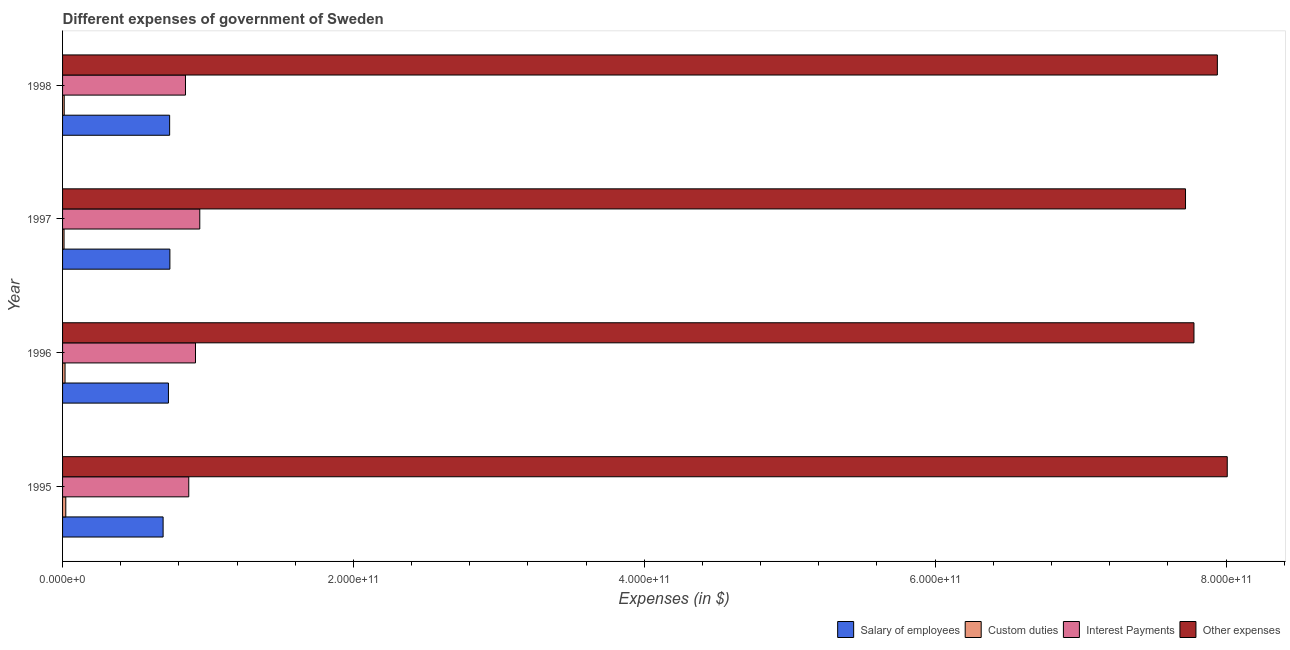How many different coloured bars are there?
Your answer should be compact. 4. Are the number of bars on each tick of the Y-axis equal?
Keep it short and to the point. Yes. How many bars are there on the 3rd tick from the bottom?
Provide a short and direct response. 4. What is the label of the 2nd group of bars from the top?
Offer a very short reply. 1997. What is the amount spent on salary of employees in 1996?
Provide a succinct answer. 7.28e+1. Across all years, what is the maximum amount spent on salary of employees?
Offer a terse response. 7.38e+1. Across all years, what is the minimum amount spent on custom duties?
Provide a succinct answer. 1.02e+09. In which year was the amount spent on salary of employees maximum?
Give a very brief answer. 1997. In which year was the amount spent on interest payments minimum?
Keep it short and to the point. 1998. What is the total amount spent on other expenses in the graph?
Provide a succinct answer. 3.15e+12. What is the difference between the amount spent on interest payments in 1997 and that in 1998?
Offer a very short reply. 9.84e+09. What is the difference between the amount spent on salary of employees in 1996 and the amount spent on interest payments in 1998?
Ensure brevity in your answer.  -1.17e+1. What is the average amount spent on other expenses per year?
Give a very brief answer. 7.86e+11. In the year 1998, what is the difference between the amount spent on other expenses and amount spent on interest payments?
Your response must be concise. 7.10e+11. In how many years, is the amount spent on other expenses greater than 400000000000 $?
Provide a short and direct response. 4. Is the difference between the amount spent on interest payments in 1995 and 1997 greater than the difference between the amount spent on other expenses in 1995 and 1997?
Offer a terse response. No. What is the difference between the highest and the second highest amount spent on interest payments?
Your answer should be compact. 2.94e+09. What is the difference between the highest and the lowest amount spent on other expenses?
Provide a succinct answer. 2.87e+1. In how many years, is the amount spent on interest payments greater than the average amount spent on interest payments taken over all years?
Your response must be concise. 2. Is it the case that in every year, the sum of the amount spent on custom duties and amount spent on other expenses is greater than the sum of amount spent on salary of employees and amount spent on interest payments?
Ensure brevity in your answer.  No. What does the 4th bar from the top in 1997 represents?
Your answer should be compact. Salary of employees. What does the 3rd bar from the bottom in 1998 represents?
Your answer should be very brief. Interest Payments. Are all the bars in the graph horizontal?
Keep it short and to the point. Yes. How many years are there in the graph?
Your response must be concise. 4. What is the difference between two consecutive major ticks on the X-axis?
Offer a very short reply. 2.00e+11. Are the values on the major ticks of X-axis written in scientific E-notation?
Offer a very short reply. Yes. Does the graph contain any zero values?
Provide a short and direct response. No. What is the title of the graph?
Offer a terse response. Different expenses of government of Sweden. Does "Industry" appear as one of the legend labels in the graph?
Provide a short and direct response. No. What is the label or title of the X-axis?
Make the answer very short. Expenses (in $). What is the label or title of the Y-axis?
Give a very brief answer. Year. What is the Expenses (in $) in Salary of employees in 1995?
Give a very brief answer. 6.91e+1. What is the Expenses (in $) in Custom duties in 1995?
Your answer should be compact. 2.22e+09. What is the Expenses (in $) of Interest Payments in 1995?
Make the answer very short. 8.68e+1. What is the Expenses (in $) of Other expenses in 1995?
Provide a short and direct response. 8.01e+11. What is the Expenses (in $) of Salary of employees in 1996?
Your response must be concise. 7.28e+1. What is the Expenses (in $) in Custom duties in 1996?
Give a very brief answer. 1.70e+09. What is the Expenses (in $) in Interest Payments in 1996?
Offer a terse response. 9.14e+1. What is the Expenses (in $) of Other expenses in 1996?
Provide a short and direct response. 7.78e+11. What is the Expenses (in $) of Salary of employees in 1997?
Your answer should be very brief. 7.38e+1. What is the Expenses (in $) of Custom duties in 1997?
Provide a succinct answer. 1.02e+09. What is the Expenses (in $) of Interest Payments in 1997?
Ensure brevity in your answer.  9.44e+1. What is the Expenses (in $) of Other expenses in 1997?
Provide a short and direct response. 7.72e+11. What is the Expenses (in $) of Salary of employees in 1998?
Your answer should be very brief. 7.36e+1. What is the Expenses (in $) of Custom duties in 1998?
Keep it short and to the point. 1.14e+09. What is the Expenses (in $) of Interest Payments in 1998?
Give a very brief answer. 8.45e+1. What is the Expenses (in $) of Other expenses in 1998?
Offer a very short reply. 7.94e+11. Across all years, what is the maximum Expenses (in $) in Salary of employees?
Your answer should be very brief. 7.38e+1. Across all years, what is the maximum Expenses (in $) in Custom duties?
Keep it short and to the point. 2.22e+09. Across all years, what is the maximum Expenses (in $) in Interest Payments?
Offer a very short reply. 9.44e+1. Across all years, what is the maximum Expenses (in $) of Other expenses?
Provide a succinct answer. 8.01e+11. Across all years, what is the minimum Expenses (in $) of Salary of employees?
Provide a short and direct response. 6.91e+1. Across all years, what is the minimum Expenses (in $) in Custom duties?
Provide a succinct answer. 1.02e+09. Across all years, what is the minimum Expenses (in $) in Interest Payments?
Give a very brief answer. 8.45e+1. Across all years, what is the minimum Expenses (in $) of Other expenses?
Ensure brevity in your answer.  7.72e+11. What is the total Expenses (in $) of Salary of employees in the graph?
Ensure brevity in your answer.  2.89e+11. What is the total Expenses (in $) in Custom duties in the graph?
Keep it short and to the point. 6.08e+09. What is the total Expenses (in $) in Interest Payments in the graph?
Give a very brief answer. 3.57e+11. What is the total Expenses (in $) of Other expenses in the graph?
Offer a terse response. 3.15e+12. What is the difference between the Expenses (in $) in Salary of employees in 1995 and that in 1996?
Make the answer very short. -3.67e+09. What is the difference between the Expenses (in $) of Custom duties in 1995 and that in 1996?
Provide a succinct answer. 5.17e+08. What is the difference between the Expenses (in $) in Interest Payments in 1995 and that in 1996?
Make the answer very short. -4.64e+09. What is the difference between the Expenses (in $) in Other expenses in 1995 and that in 1996?
Keep it short and to the point. 2.29e+1. What is the difference between the Expenses (in $) in Salary of employees in 1995 and that in 1997?
Make the answer very short. -4.67e+09. What is the difference between the Expenses (in $) in Custom duties in 1995 and that in 1997?
Offer a terse response. 1.20e+09. What is the difference between the Expenses (in $) of Interest Payments in 1995 and that in 1997?
Provide a short and direct response. -7.58e+09. What is the difference between the Expenses (in $) in Other expenses in 1995 and that in 1997?
Ensure brevity in your answer.  2.87e+1. What is the difference between the Expenses (in $) of Salary of employees in 1995 and that in 1998?
Offer a very short reply. -4.49e+09. What is the difference between the Expenses (in $) of Custom duties in 1995 and that in 1998?
Your answer should be very brief. 1.08e+09. What is the difference between the Expenses (in $) in Interest Payments in 1995 and that in 1998?
Make the answer very short. 2.26e+09. What is the difference between the Expenses (in $) of Other expenses in 1995 and that in 1998?
Your answer should be very brief. 6.80e+09. What is the difference between the Expenses (in $) in Salary of employees in 1996 and that in 1997?
Ensure brevity in your answer.  -1.00e+09. What is the difference between the Expenses (in $) of Custom duties in 1996 and that in 1997?
Make the answer very short. 6.84e+08. What is the difference between the Expenses (in $) in Interest Payments in 1996 and that in 1997?
Your response must be concise. -2.94e+09. What is the difference between the Expenses (in $) in Other expenses in 1996 and that in 1997?
Give a very brief answer. 5.81e+09. What is the difference between the Expenses (in $) of Salary of employees in 1996 and that in 1998?
Provide a succinct answer. -8.25e+08. What is the difference between the Expenses (in $) of Custom duties in 1996 and that in 1998?
Provide a short and direct response. 5.65e+08. What is the difference between the Expenses (in $) in Interest Payments in 1996 and that in 1998?
Your answer should be compact. 6.89e+09. What is the difference between the Expenses (in $) of Other expenses in 1996 and that in 1998?
Offer a very short reply. -1.61e+1. What is the difference between the Expenses (in $) in Salary of employees in 1997 and that in 1998?
Offer a terse response. 1.75e+08. What is the difference between the Expenses (in $) of Custom duties in 1997 and that in 1998?
Your answer should be compact. -1.19e+08. What is the difference between the Expenses (in $) in Interest Payments in 1997 and that in 1998?
Your answer should be compact. 9.84e+09. What is the difference between the Expenses (in $) of Other expenses in 1997 and that in 1998?
Make the answer very short. -2.19e+1. What is the difference between the Expenses (in $) in Salary of employees in 1995 and the Expenses (in $) in Custom duties in 1996?
Offer a very short reply. 6.74e+1. What is the difference between the Expenses (in $) of Salary of employees in 1995 and the Expenses (in $) of Interest Payments in 1996?
Give a very brief answer. -2.23e+1. What is the difference between the Expenses (in $) of Salary of employees in 1995 and the Expenses (in $) of Other expenses in 1996?
Provide a succinct answer. -7.09e+11. What is the difference between the Expenses (in $) of Custom duties in 1995 and the Expenses (in $) of Interest Payments in 1996?
Provide a short and direct response. -8.92e+1. What is the difference between the Expenses (in $) of Custom duties in 1995 and the Expenses (in $) of Other expenses in 1996?
Your answer should be compact. -7.76e+11. What is the difference between the Expenses (in $) in Interest Payments in 1995 and the Expenses (in $) in Other expenses in 1996?
Your answer should be compact. -6.91e+11. What is the difference between the Expenses (in $) of Salary of employees in 1995 and the Expenses (in $) of Custom duties in 1997?
Provide a succinct answer. 6.81e+1. What is the difference between the Expenses (in $) in Salary of employees in 1995 and the Expenses (in $) in Interest Payments in 1997?
Your answer should be compact. -2.52e+1. What is the difference between the Expenses (in $) of Salary of employees in 1995 and the Expenses (in $) of Other expenses in 1997?
Keep it short and to the point. -7.03e+11. What is the difference between the Expenses (in $) of Custom duties in 1995 and the Expenses (in $) of Interest Payments in 1997?
Your answer should be very brief. -9.21e+1. What is the difference between the Expenses (in $) in Custom duties in 1995 and the Expenses (in $) in Other expenses in 1997?
Provide a short and direct response. -7.70e+11. What is the difference between the Expenses (in $) of Interest Payments in 1995 and the Expenses (in $) of Other expenses in 1997?
Keep it short and to the point. -6.85e+11. What is the difference between the Expenses (in $) in Salary of employees in 1995 and the Expenses (in $) in Custom duties in 1998?
Your answer should be compact. 6.80e+1. What is the difference between the Expenses (in $) of Salary of employees in 1995 and the Expenses (in $) of Interest Payments in 1998?
Provide a short and direct response. -1.54e+1. What is the difference between the Expenses (in $) in Salary of employees in 1995 and the Expenses (in $) in Other expenses in 1998?
Offer a very short reply. -7.25e+11. What is the difference between the Expenses (in $) in Custom duties in 1995 and the Expenses (in $) in Interest Payments in 1998?
Give a very brief answer. -8.23e+1. What is the difference between the Expenses (in $) in Custom duties in 1995 and the Expenses (in $) in Other expenses in 1998?
Your answer should be compact. -7.92e+11. What is the difference between the Expenses (in $) in Interest Payments in 1995 and the Expenses (in $) in Other expenses in 1998?
Provide a succinct answer. -7.07e+11. What is the difference between the Expenses (in $) of Salary of employees in 1996 and the Expenses (in $) of Custom duties in 1997?
Your response must be concise. 7.18e+1. What is the difference between the Expenses (in $) of Salary of employees in 1996 and the Expenses (in $) of Interest Payments in 1997?
Ensure brevity in your answer.  -2.16e+1. What is the difference between the Expenses (in $) in Salary of employees in 1996 and the Expenses (in $) in Other expenses in 1997?
Make the answer very short. -6.99e+11. What is the difference between the Expenses (in $) of Custom duties in 1996 and the Expenses (in $) of Interest Payments in 1997?
Your answer should be compact. -9.26e+1. What is the difference between the Expenses (in $) of Custom duties in 1996 and the Expenses (in $) of Other expenses in 1997?
Offer a terse response. -7.70e+11. What is the difference between the Expenses (in $) in Interest Payments in 1996 and the Expenses (in $) in Other expenses in 1997?
Your response must be concise. -6.81e+11. What is the difference between the Expenses (in $) of Salary of employees in 1996 and the Expenses (in $) of Custom duties in 1998?
Make the answer very short. 7.17e+1. What is the difference between the Expenses (in $) of Salary of employees in 1996 and the Expenses (in $) of Interest Payments in 1998?
Keep it short and to the point. -1.17e+1. What is the difference between the Expenses (in $) of Salary of employees in 1996 and the Expenses (in $) of Other expenses in 1998?
Give a very brief answer. -7.21e+11. What is the difference between the Expenses (in $) in Custom duties in 1996 and the Expenses (in $) in Interest Payments in 1998?
Give a very brief answer. -8.28e+1. What is the difference between the Expenses (in $) in Custom duties in 1996 and the Expenses (in $) in Other expenses in 1998?
Your response must be concise. -7.92e+11. What is the difference between the Expenses (in $) of Interest Payments in 1996 and the Expenses (in $) of Other expenses in 1998?
Ensure brevity in your answer.  -7.03e+11. What is the difference between the Expenses (in $) of Salary of employees in 1997 and the Expenses (in $) of Custom duties in 1998?
Offer a very short reply. 7.27e+1. What is the difference between the Expenses (in $) of Salary of employees in 1997 and the Expenses (in $) of Interest Payments in 1998?
Offer a very short reply. -1.07e+1. What is the difference between the Expenses (in $) in Salary of employees in 1997 and the Expenses (in $) in Other expenses in 1998?
Provide a succinct answer. -7.20e+11. What is the difference between the Expenses (in $) of Custom duties in 1997 and the Expenses (in $) of Interest Payments in 1998?
Keep it short and to the point. -8.35e+1. What is the difference between the Expenses (in $) of Custom duties in 1997 and the Expenses (in $) of Other expenses in 1998?
Give a very brief answer. -7.93e+11. What is the difference between the Expenses (in $) of Interest Payments in 1997 and the Expenses (in $) of Other expenses in 1998?
Provide a short and direct response. -7.00e+11. What is the average Expenses (in $) of Salary of employees per year?
Your answer should be compact. 7.23e+1. What is the average Expenses (in $) in Custom duties per year?
Offer a very short reply. 1.52e+09. What is the average Expenses (in $) in Interest Payments per year?
Keep it short and to the point. 8.93e+1. What is the average Expenses (in $) of Other expenses per year?
Offer a very short reply. 7.86e+11. In the year 1995, what is the difference between the Expenses (in $) of Salary of employees and Expenses (in $) of Custom duties?
Make the answer very short. 6.69e+1. In the year 1995, what is the difference between the Expenses (in $) of Salary of employees and Expenses (in $) of Interest Payments?
Your answer should be compact. -1.76e+1. In the year 1995, what is the difference between the Expenses (in $) of Salary of employees and Expenses (in $) of Other expenses?
Your answer should be compact. -7.32e+11. In the year 1995, what is the difference between the Expenses (in $) in Custom duties and Expenses (in $) in Interest Payments?
Give a very brief answer. -8.46e+1. In the year 1995, what is the difference between the Expenses (in $) in Custom duties and Expenses (in $) in Other expenses?
Provide a short and direct response. -7.99e+11. In the year 1995, what is the difference between the Expenses (in $) of Interest Payments and Expenses (in $) of Other expenses?
Your answer should be compact. -7.14e+11. In the year 1996, what is the difference between the Expenses (in $) in Salary of employees and Expenses (in $) in Custom duties?
Give a very brief answer. 7.11e+1. In the year 1996, what is the difference between the Expenses (in $) of Salary of employees and Expenses (in $) of Interest Payments?
Offer a very short reply. -1.86e+1. In the year 1996, what is the difference between the Expenses (in $) of Salary of employees and Expenses (in $) of Other expenses?
Your answer should be very brief. -7.05e+11. In the year 1996, what is the difference between the Expenses (in $) in Custom duties and Expenses (in $) in Interest Payments?
Ensure brevity in your answer.  -8.97e+1. In the year 1996, what is the difference between the Expenses (in $) of Custom duties and Expenses (in $) of Other expenses?
Provide a short and direct response. -7.76e+11. In the year 1996, what is the difference between the Expenses (in $) in Interest Payments and Expenses (in $) in Other expenses?
Offer a very short reply. -6.87e+11. In the year 1997, what is the difference between the Expenses (in $) in Salary of employees and Expenses (in $) in Custom duties?
Keep it short and to the point. 7.28e+1. In the year 1997, what is the difference between the Expenses (in $) of Salary of employees and Expenses (in $) of Interest Payments?
Keep it short and to the point. -2.06e+1. In the year 1997, what is the difference between the Expenses (in $) of Salary of employees and Expenses (in $) of Other expenses?
Provide a short and direct response. -6.98e+11. In the year 1997, what is the difference between the Expenses (in $) of Custom duties and Expenses (in $) of Interest Payments?
Your response must be concise. -9.33e+1. In the year 1997, what is the difference between the Expenses (in $) in Custom duties and Expenses (in $) in Other expenses?
Your answer should be very brief. -7.71e+11. In the year 1997, what is the difference between the Expenses (in $) of Interest Payments and Expenses (in $) of Other expenses?
Provide a short and direct response. -6.78e+11. In the year 1998, what is the difference between the Expenses (in $) in Salary of employees and Expenses (in $) in Custom duties?
Your answer should be very brief. 7.25e+1. In the year 1998, what is the difference between the Expenses (in $) in Salary of employees and Expenses (in $) in Interest Payments?
Give a very brief answer. -1.09e+1. In the year 1998, what is the difference between the Expenses (in $) in Salary of employees and Expenses (in $) in Other expenses?
Your answer should be very brief. -7.20e+11. In the year 1998, what is the difference between the Expenses (in $) in Custom duties and Expenses (in $) in Interest Payments?
Your answer should be very brief. -8.34e+1. In the year 1998, what is the difference between the Expenses (in $) of Custom duties and Expenses (in $) of Other expenses?
Give a very brief answer. -7.93e+11. In the year 1998, what is the difference between the Expenses (in $) in Interest Payments and Expenses (in $) in Other expenses?
Provide a short and direct response. -7.10e+11. What is the ratio of the Expenses (in $) of Salary of employees in 1995 to that in 1996?
Ensure brevity in your answer.  0.95. What is the ratio of the Expenses (in $) in Custom duties in 1995 to that in 1996?
Provide a succinct answer. 1.3. What is the ratio of the Expenses (in $) of Interest Payments in 1995 to that in 1996?
Provide a short and direct response. 0.95. What is the ratio of the Expenses (in $) of Other expenses in 1995 to that in 1996?
Keep it short and to the point. 1.03. What is the ratio of the Expenses (in $) of Salary of employees in 1995 to that in 1997?
Your answer should be very brief. 0.94. What is the ratio of the Expenses (in $) of Custom duties in 1995 to that in 1997?
Provide a short and direct response. 2.18. What is the ratio of the Expenses (in $) in Interest Payments in 1995 to that in 1997?
Offer a very short reply. 0.92. What is the ratio of the Expenses (in $) in Other expenses in 1995 to that in 1997?
Keep it short and to the point. 1.04. What is the ratio of the Expenses (in $) of Salary of employees in 1995 to that in 1998?
Your response must be concise. 0.94. What is the ratio of the Expenses (in $) in Custom duties in 1995 to that in 1998?
Ensure brevity in your answer.  1.95. What is the ratio of the Expenses (in $) in Interest Payments in 1995 to that in 1998?
Offer a very short reply. 1.03. What is the ratio of the Expenses (in $) in Other expenses in 1995 to that in 1998?
Provide a short and direct response. 1.01. What is the ratio of the Expenses (in $) in Salary of employees in 1996 to that in 1997?
Make the answer very short. 0.99. What is the ratio of the Expenses (in $) of Custom duties in 1996 to that in 1997?
Provide a succinct answer. 1.67. What is the ratio of the Expenses (in $) in Interest Payments in 1996 to that in 1997?
Your response must be concise. 0.97. What is the ratio of the Expenses (in $) in Other expenses in 1996 to that in 1997?
Your answer should be compact. 1.01. What is the ratio of the Expenses (in $) in Custom duties in 1996 to that in 1998?
Provide a short and direct response. 1.5. What is the ratio of the Expenses (in $) of Interest Payments in 1996 to that in 1998?
Make the answer very short. 1.08. What is the ratio of the Expenses (in $) in Other expenses in 1996 to that in 1998?
Offer a terse response. 0.98. What is the ratio of the Expenses (in $) of Custom duties in 1997 to that in 1998?
Ensure brevity in your answer.  0.9. What is the ratio of the Expenses (in $) in Interest Payments in 1997 to that in 1998?
Your response must be concise. 1.12. What is the ratio of the Expenses (in $) of Other expenses in 1997 to that in 1998?
Offer a terse response. 0.97. What is the difference between the highest and the second highest Expenses (in $) of Salary of employees?
Provide a succinct answer. 1.75e+08. What is the difference between the highest and the second highest Expenses (in $) in Custom duties?
Give a very brief answer. 5.17e+08. What is the difference between the highest and the second highest Expenses (in $) of Interest Payments?
Offer a terse response. 2.94e+09. What is the difference between the highest and the second highest Expenses (in $) of Other expenses?
Your answer should be very brief. 6.80e+09. What is the difference between the highest and the lowest Expenses (in $) of Salary of employees?
Your response must be concise. 4.67e+09. What is the difference between the highest and the lowest Expenses (in $) in Custom duties?
Ensure brevity in your answer.  1.20e+09. What is the difference between the highest and the lowest Expenses (in $) in Interest Payments?
Provide a short and direct response. 9.84e+09. What is the difference between the highest and the lowest Expenses (in $) of Other expenses?
Keep it short and to the point. 2.87e+1. 